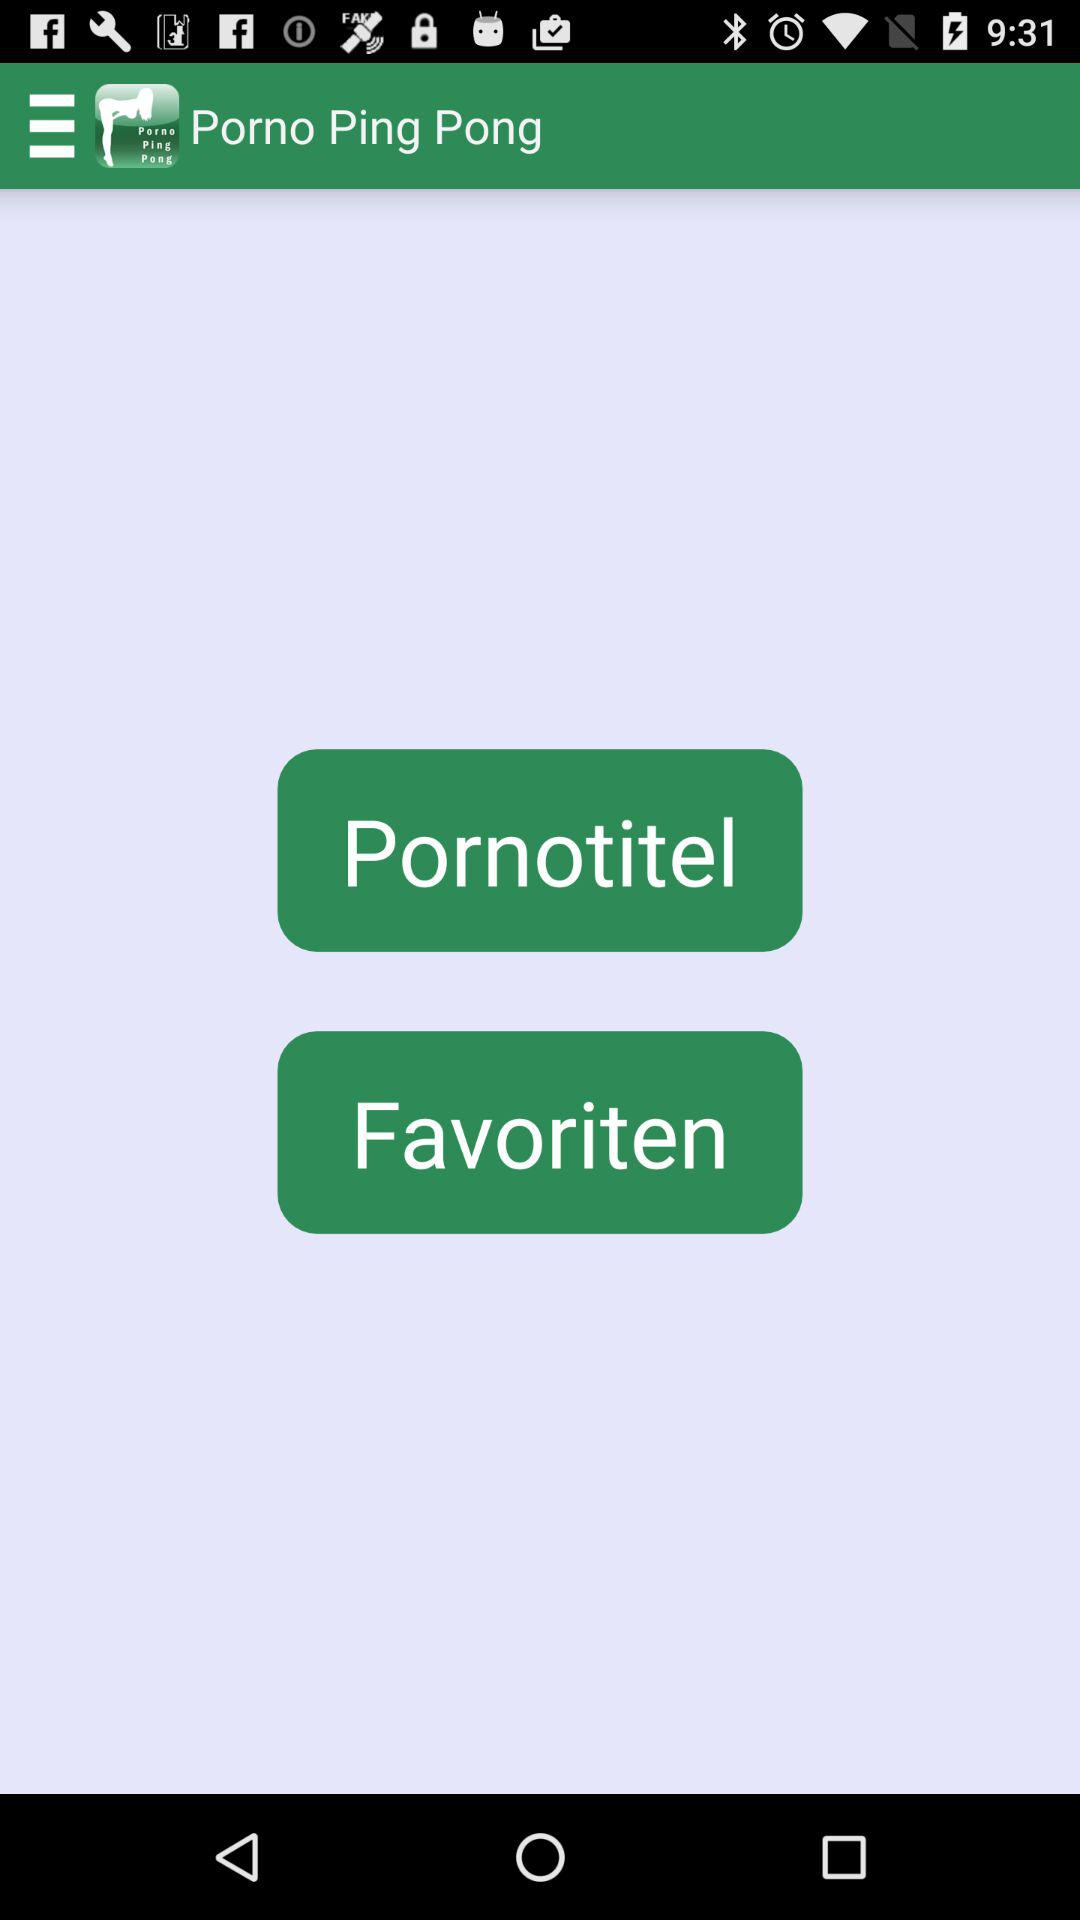Which porn is listed as a favorite?
When the provided information is insufficient, respond with <no answer>. <no answer> 